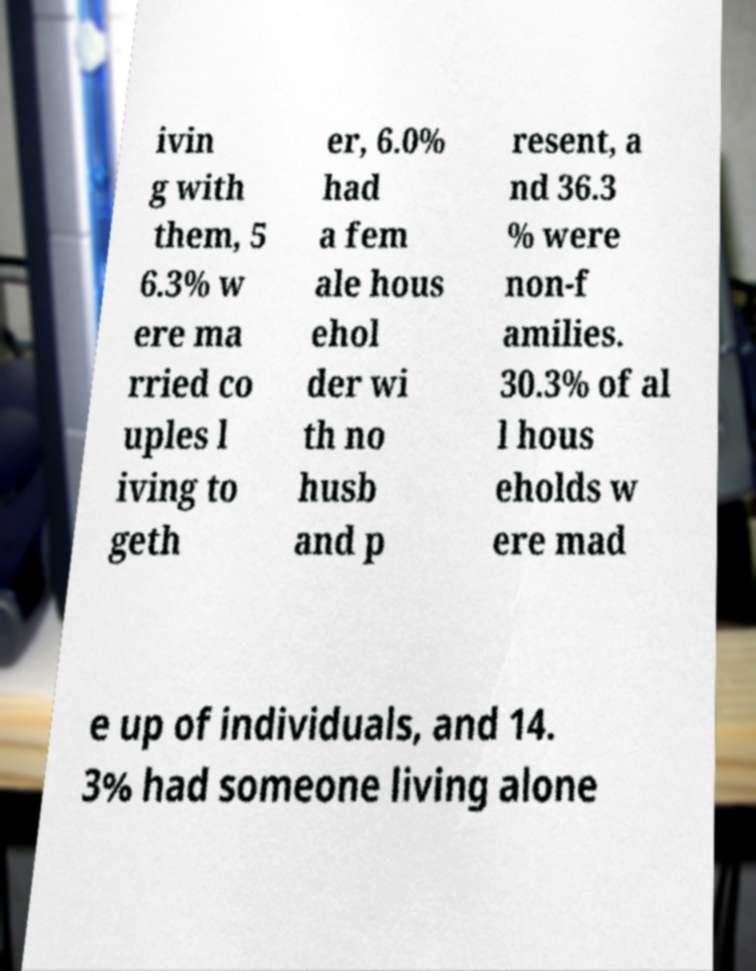Please identify and transcribe the text found in this image. ivin g with them, 5 6.3% w ere ma rried co uples l iving to geth er, 6.0% had a fem ale hous ehol der wi th no husb and p resent, a nd 36.3 % were non-f amilies. 30.3% of al l hous eholds w ere mad e up of individuals, and 14. 3% had someone living alone 